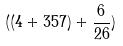<formula> <loc_0><loc_0><loc_500><loc_500>( ( 4 + 3 5 7 ) + \frac { 6 } { 2 6 } )</formula> 